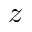Convert formula to latex. <formula><loc_0><loc_0><loc_500><loc_500>z</formula> 